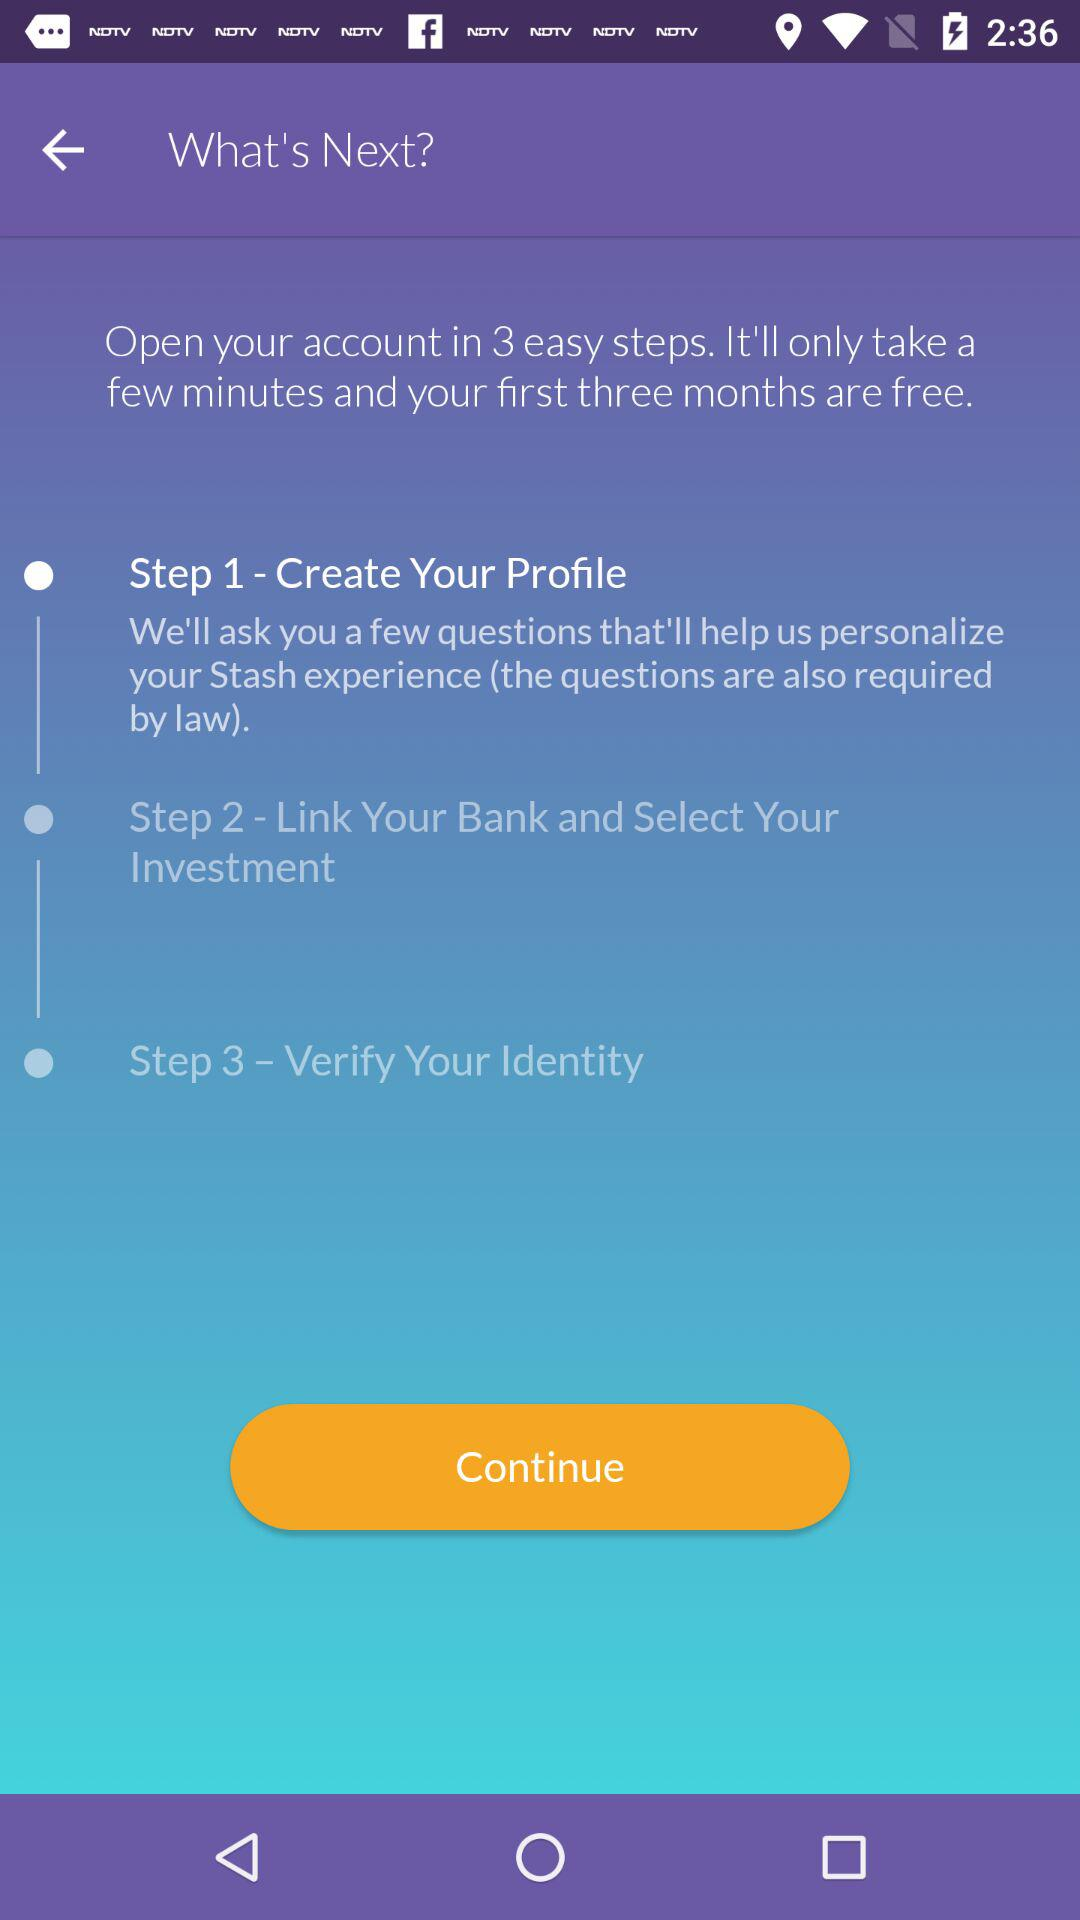How many steps are there in the process?
Answer the question using a single word or phrase. 3 